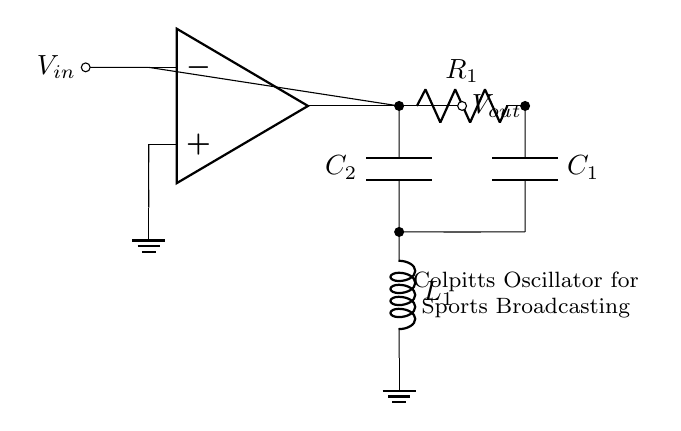What is the type of amplifier used in this circuit? The circuit uses an operational amplifier, which is shown symbolically at the center of the diagram.
Answer: operational amplifier What are the two capacitors labeled in the circuit? The capacitors in the circuit are labeled C1 and C2, located in the feedback network of the oscillator.
Answer: C1 and C2 What is the role of the inductor in this oscillator circuit? The inductor, labeled L1, is part of the tank circuit that helps determine the oscillation frequency along with the capacitors.
Answer: frequency determination How does the output voltage relate to the input voltage in this Colpitts oscillator? The output voltage, labeled Vout, is the amplified version of the input voltage Vin because of the feedback mechanism created by the capacitor and inductor configuration.
Answer: amplified What is the purpose of the resistors in the oscillator circuit? The resistor R1 is used to set the gain of the operational amplifier and stabilize the circuit's oscillations.
Answer: gain stabilization What is the overall configuration of the components in this oscillator? The components are configured as a feedback loop with the operational amplifier, capacitors, and inductor forming a Colpitts topology which is essential for sustained oscillations.
Answer: feedback loop How would changing the values of C1 and C2 affect the oscillator? Changing the values of C1 and C2 would alter the frequency of oscillation, as they affect the reactance in the tank circuit used for oscillation.
Answer: change frequency 